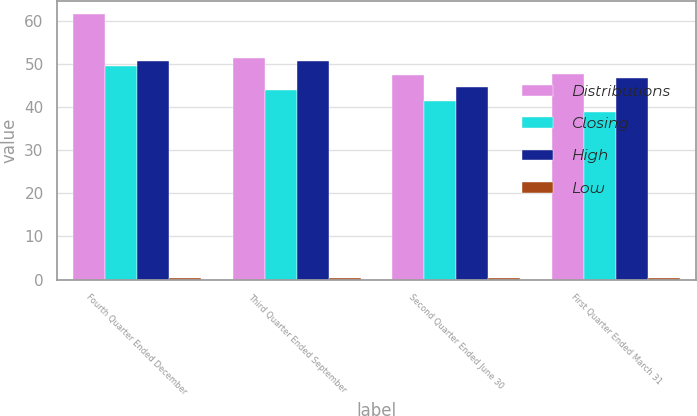<chart> <loc_0><loc_0><loc_500><loc_500><stacked_bar_chart><ecel><fcel>Fourth Quarter Ended December<fcel>Third Quarter Ended September<fcel>Second Quarter Ended June 30<fcel>First Quarter Ended March 31<nl><fcel>Distributions<fcel>61.5<fcel>51.35<fcel>47.47<fcel>47.74<nl><fcel>Closing<fcel>49.42<fcel>44.04<fcel>41.45<fcel>38.84<nl><fcel>High<fcel>50.75<fcel>50.58<fcel>44.73<fcel>46.79<nl><fcel>Low<fcel>0.46<fcel>0.44<fcel>0.44<fcel>0.44<nl></chart> 